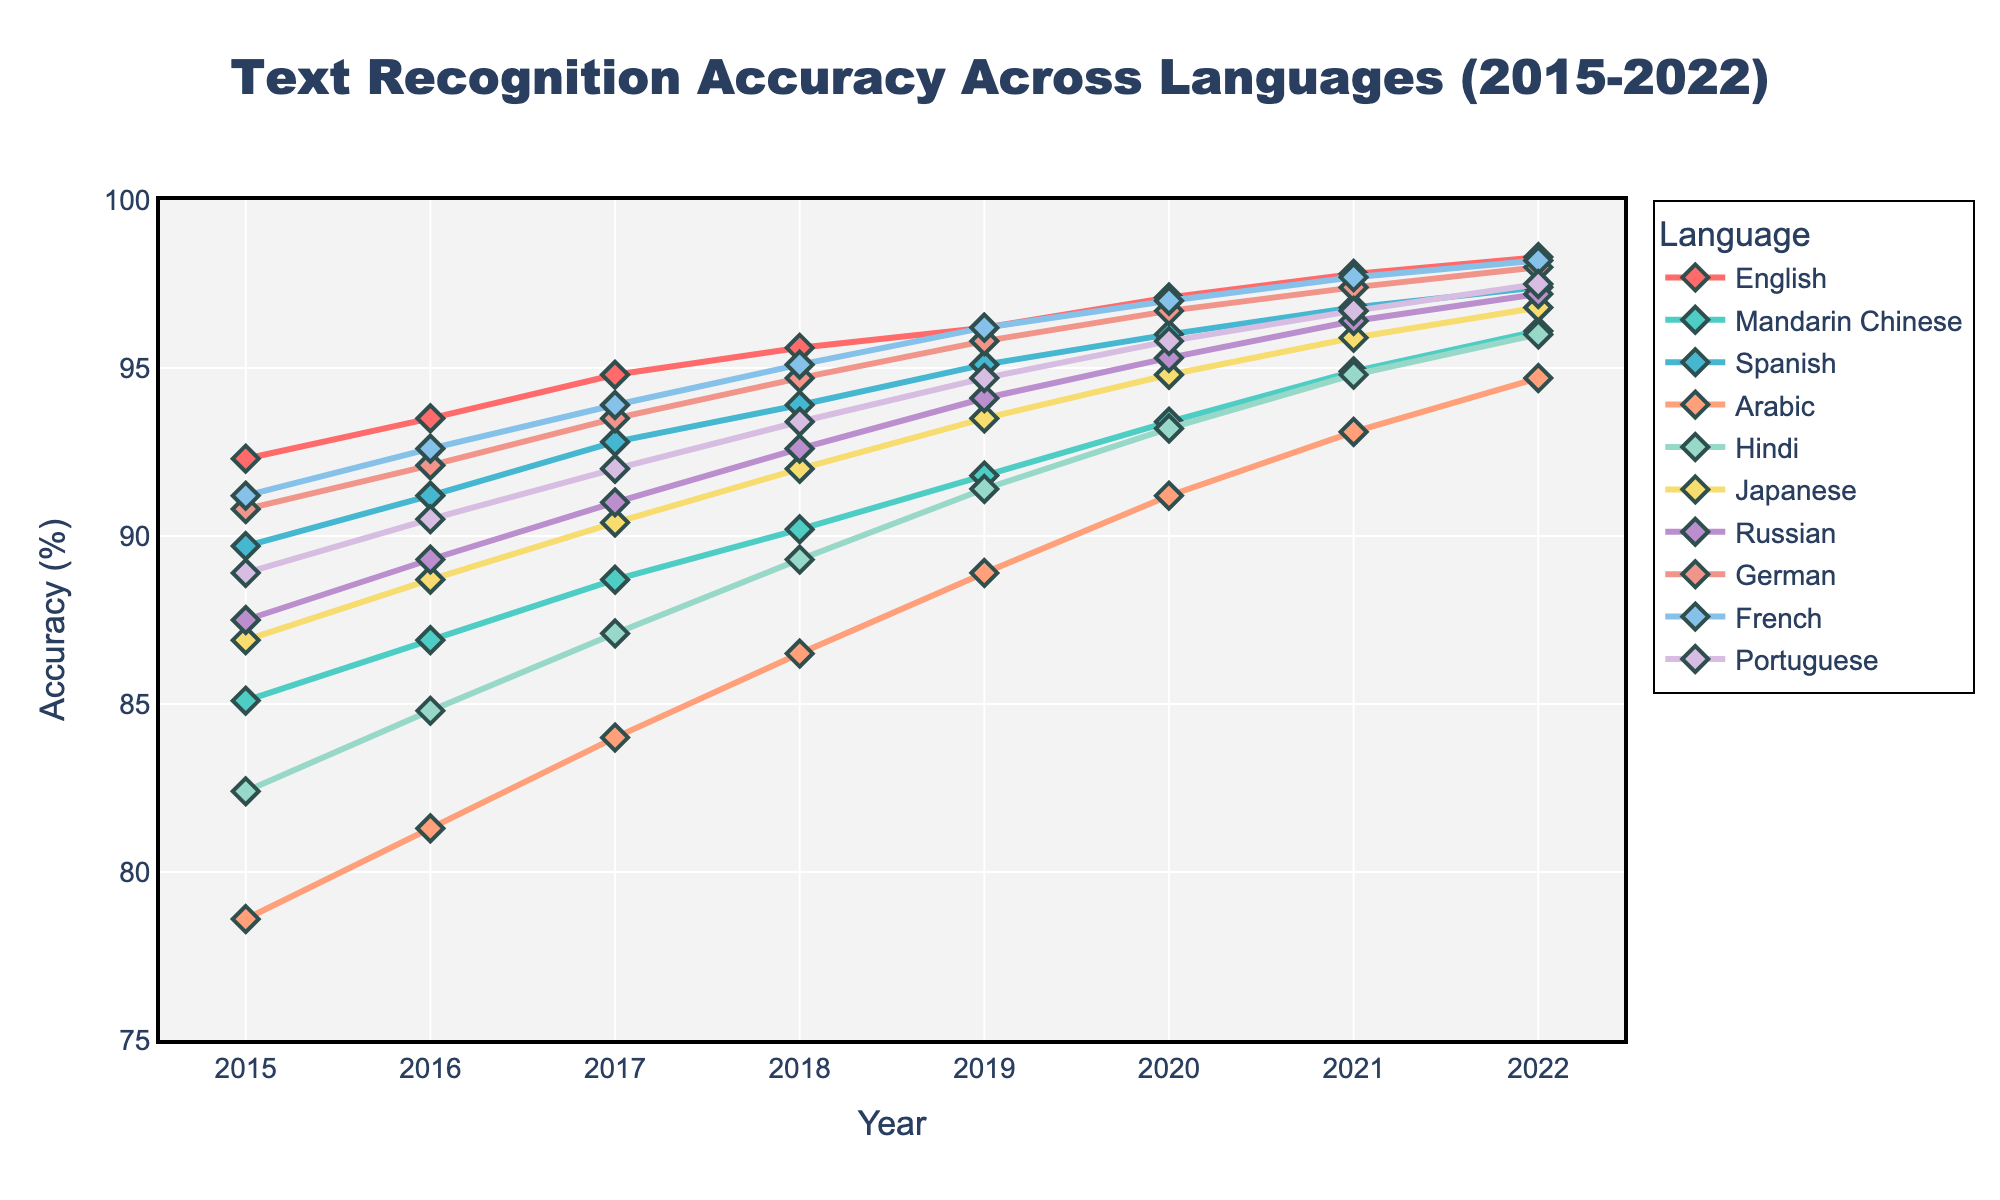What language had the highest accuracy rate in 2022? In 2022, the language with the highest accuracy rate is determined by looking at the data points for all languages in the year 2022. The English language had an accuracy rate of 98.3%, which is the highest among all the languages listed.
Answer: English Which language showed the greatest improvement in accuracy from 2015 to 2022? To find the language with the greatest improvement, we calculate the difference in accuracy from 2015 to 2022 for each language. Mandarin Chinese improved from 85.1% in 2015 to 96.1% in 2022, which is a difference of 11.0 percentage points, the highest improvement among all the languages.
Answer: Mandarin Chinese What is the average accuracy rate for Spanish across all years? The accuracy rates for Spanish across all years are 89.7, 91.2, 92.8, 93.9, 95.1, 96.0, 96.8, and 97.4. Adding these gives us 752.9. Dividing by the number of years (8) gives an average rate of 94.1%.
Answer: 94.1% Did any language's accuracy rate decrease at any point from 2015 to 2022? To determine if there were any decreases, we need to compare the accuracy rates for each sequential year for all languages. All languages show either steady increases or remain constant; there are no decreases in any year for any language listed.
Answer: No Comparing Arabic and French, which language had a larger relative increase in accuracy from 2015 to 2022? For Arabic, the increase from 78.6% to 94.7% is 16.1 percentage points. For French, the increase from 91.2% to 98.2% is 7 percentage points. The relative increase is larger for Arabic.
Answer: Arabic Which language had the lowest accuracy rate in 2015 and what was the value? Looking at the accuracy rates for 2015, Arabic had the lowest accuracy rate with a value of 78.6%.
Answer: Arabic, 78.6% What is the range of accuracy rates for Japanese across the years? The accuracy rates for Japanese vary from a minimum of 86.9% in 2015 to a maximum of 96.8% in 2022, resulting in a range of 96.8% - 86.9% = 9.9 percentage points.
Answer: 9.9% How much did the accuracy rate for Russian change from 2017 to 2020? The accuracy rate for Russian in 2017 was 91.0% and in 2020 it was 95.3%. The change from 2017 to 2020 is 95.3% - 91.0% = 4.3 percentage points.
Answer: 4.3% Which two languages have accuracy rates that are closest to each other in 2019, and what are those rates? In 2019, the accuracy rates for Russian and German are very close to each other. Russian has a rate of 94.1% and German has a rate of 95.8%, resulting in a difference of just 1.7 percentage points.
Answer: Russian (94.1%) and German (95.8%) What is the trend in the accuracy rate for Hindi? To determine the trend, we observe the changes in accuracy rates over the years for Hindi. The accuracy rates are 82.4%, 84.8%, 87.1%, 89.3%, 91.4%, 93.2%, 94.8%, and 96.0% from 2015 to 2022, showing a consistent upward trend.
Answer: Increasing 